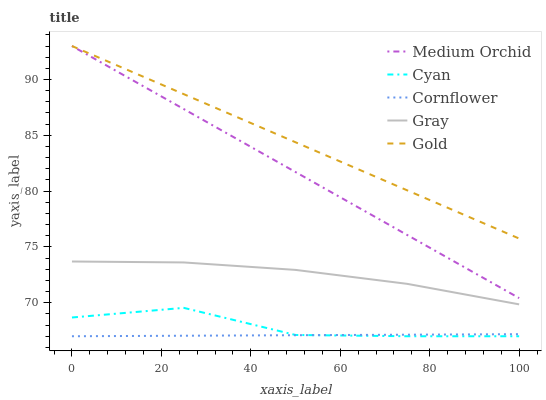Does Cornflower have the minimum area under the curve?
Answer yes or no. Yes. Does Gold have the maximum area under the curve?
Answer yes or no. Yes. Does Gray have the minimum area under the curve?
Answer yes or no. No. Does Gray have the maximum area under the curve?
Answer yes or no. No. Is Cornflower the smoothest?
Answer yes or no. Yes. Is Cyan the roughest?
Answer yes or no. Yes. Is Gray the smoothest?
Answer yes or no. No. Is Gray the roughest?
Answer yes or no. No. Does Cyan have the lowest value?
Answer yes or no. Yes. Does Gray have the lowest value?
Answer yes or no. No. Does Gold have the highest value?
Answer yes or no. Yes. Does Gray have the highest value?
Answer yes or no. No. Is Cyan less than Gray?
Answer yes or no. Yes. Is Gray greater than Cornflower?
Answer yes or no. Yes. Does Medium Orchid intersect Gold?
Answer yes or no. Yes. Is Medium Orchid less than Gold?
Answer yes or no. No. Is Medium Orchid greater than Gold?
Answer yes or no. No. Does Cyan intersect Gray?
Answer yes or no. No. 